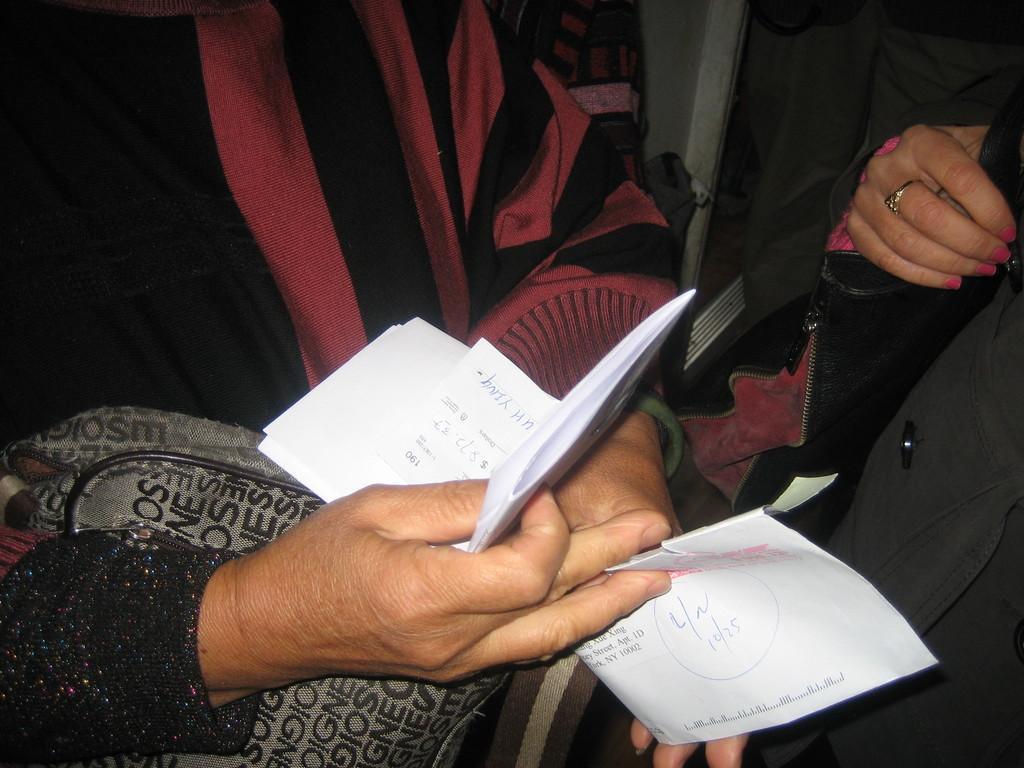Could you give a brief overview of what you see in this image? In the picture we can see hands of some persons who are holding papers in their hands. 